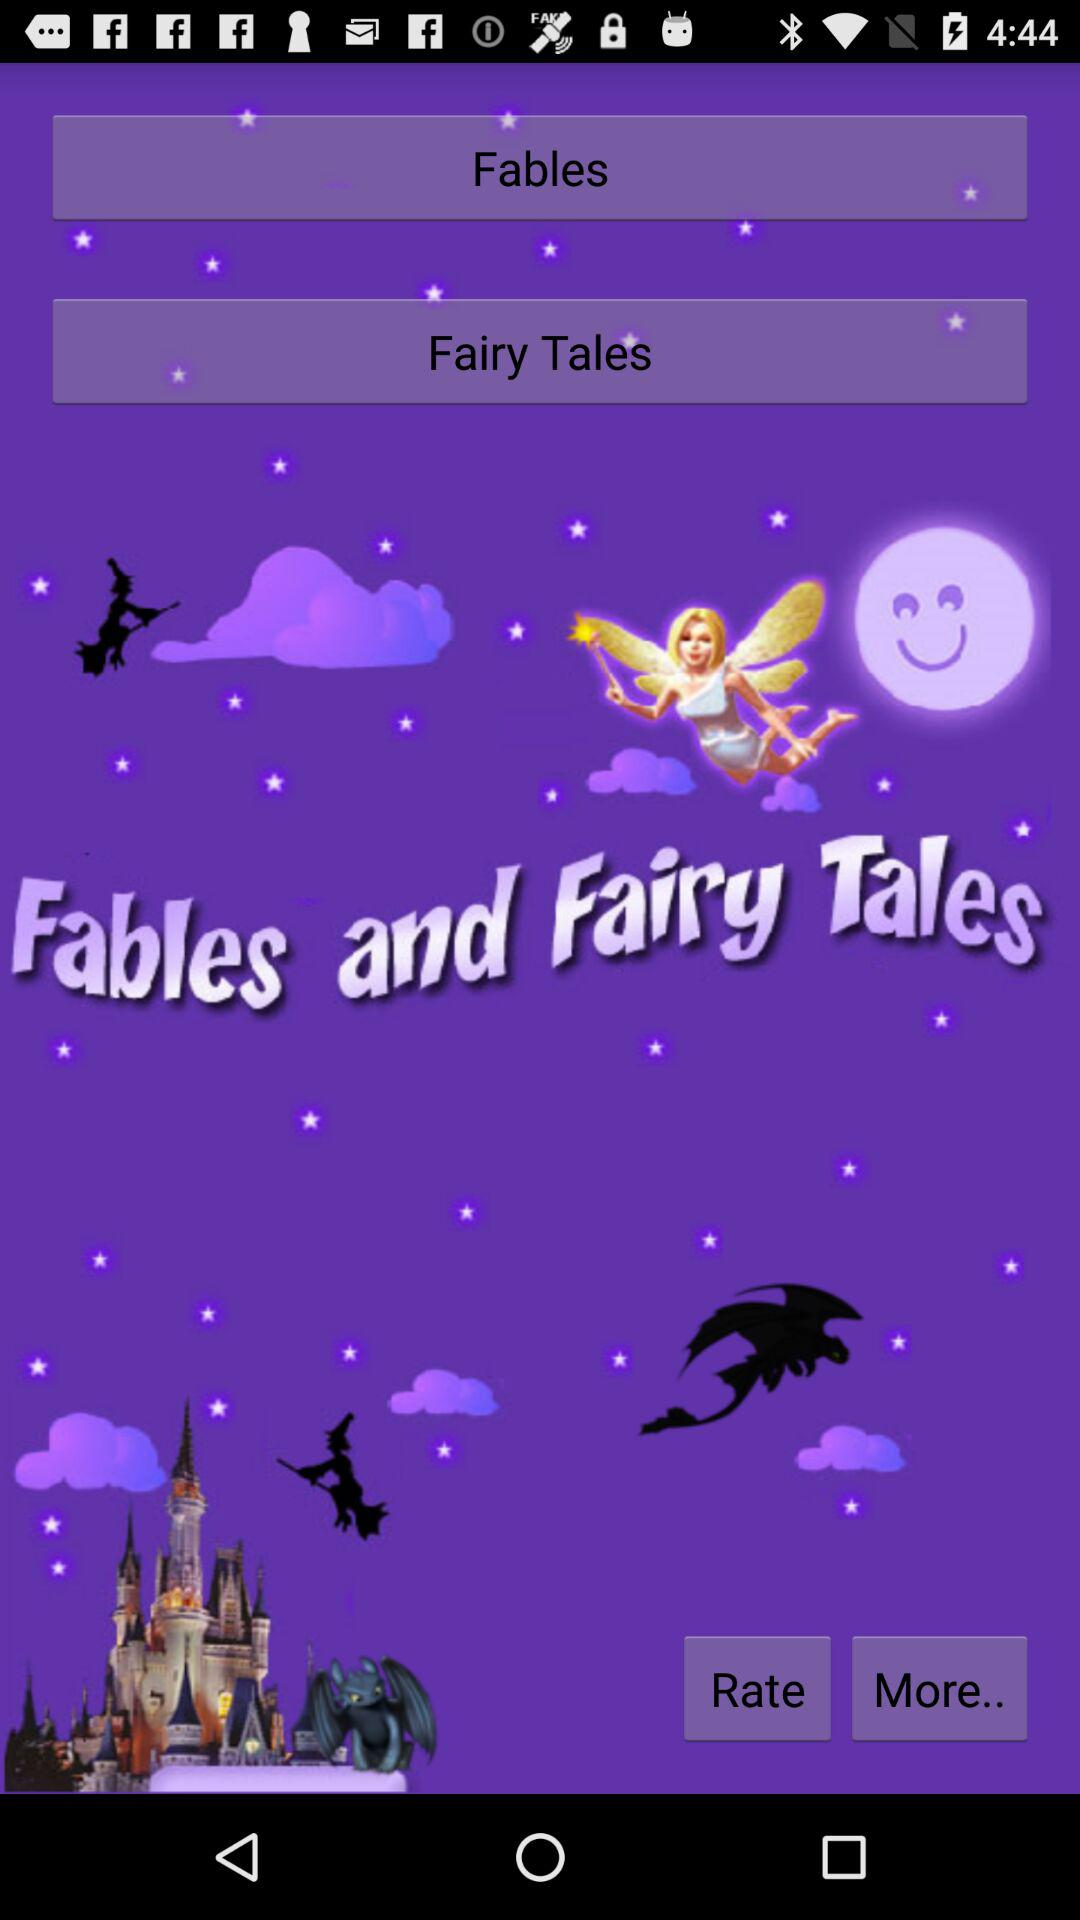How many fables are listed?
When the provided information is insufficient, respond with <no answer>. <no answer> 